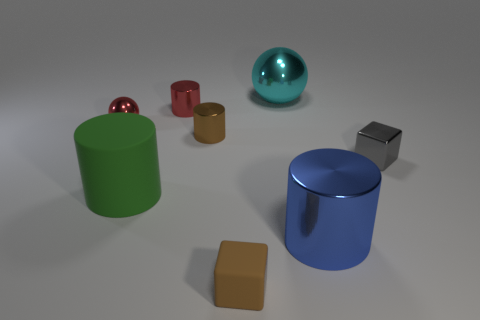Is the color of the small metal sphere the same as the tiny metal cylinder that is behind the red shiny ball?
Give a very brief answer. Yes. What size is the matte object behind the blue cylinder to the right of the small matte thing that is in front of the large blue thing?
Your response must be concise. Large. How many metallic cylinders have the same color as the tiny sphere?
Offer a very short reply. 1. What number of objects are either small red objects or metal objects that are on the left side of the small gray thing?
Offer a very short reply. 5. The large sphere has what color?
Offer a very short reply. Cyan. There is a small thing that is in front of the big blue metallic cylinder; what is its color?
Provide a succinct answer. Brown. There is a brown object that is in front of the brown metallic cylinder; what number of brown objects are to the left of it?
Your response must be concise. 1. Is the size of the brown cube the same as the green rubber thing that is behind the large blue metallic thing?
Keep it short and to the point. No. Is there a red rubber cylinder that has the same size as the gray shiny block?
Offer a terse response. No. How many things are either big cyan spheres or brown matte cubes?
Your answer should be compact. 2. 